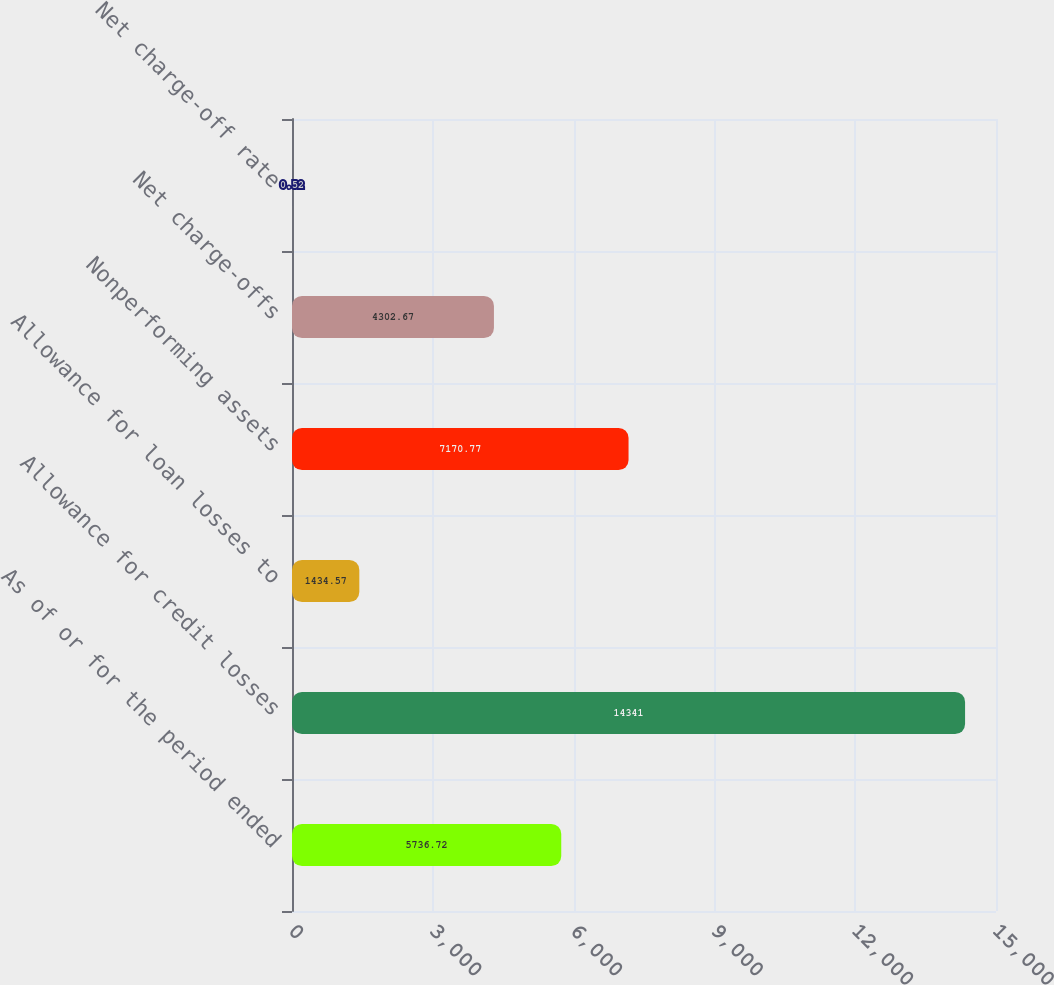<chart> <loc_0><loc_0><loc_500><loc_500><bar_chart><fcel>As of or for the period ended<fcel>Allowance for credit losses<fcel>Allowance for loan losses to<fcel>Nonperforming assets<fcel>Net charge-offs<fcel>Net charge-off rate<nl><fcel>5736.72<fcel>14341<fcel>1434.57<fcel>7170.77<fcel>4302.67<fcel>0.52<nl></chart> 